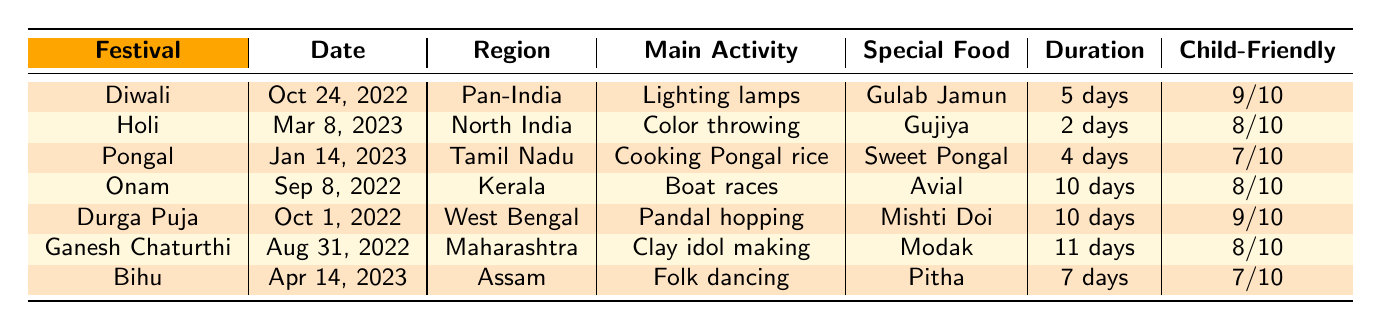What is the special food for Diwali? The table lists the special food associated with each festival. According to the row for Diwali, the special food is Gulab Jamun.
Answer: Gulab Jamun How many days does Holi last? Looking at the table, the duration of Holi is indicated as 2 days, which can be found in the same row as the festival name.
Answer: 2 days Which festival has the highest child-friendly rating? The table provides child-friendly ratings for each festival. By comparing the ratings, Diwali and Durga Puja both have a rating of 9, which is the highest.
Answer: Diwali and Durga Puja What is the main activity during Pongal? The main activity for each festival is stated in the table. For Pongal, it is "Cooking Pongal rice," which is found in its respective row.
Answer: Cooking Pongal rice Which festival occurring in Kerala lasts the longest? From the table, Onam is the festival in Kerala with a duration of 10 days, which is the longest among the festivals listed for that region.
Answer: Onam How many days is the duration of Ganesh Chaturthi compared to Holi? According to the table, Ganesh Chaturthi lasts for 11 days, while Holi lasts for 2 days. The difference in duration is 11 - 2 = 9 days.
Answer: 11 days vs. 2 days Is Bihu a child-friendly festival? The child-friendly rating for Bihu is 7, which indicates that it is relatively child-friendly, although not as high as some others, but it can still be categorized as such.
Answer: Yes What is the main activity of Onam and how many days does it last? For Onam, the main activity is "Boat races," and the duration is 10 days, both of which can be found in the corresponding row in the table.
Answer: Boat races, 10 days If you combine the durations of Holi, Pongal, and Onam, what is the total duration? The durations for Holi (2 days), Pongal (4 days), and Onam (10 days) can be summed: 2 + 4 + 10 = 16 days.
Answer: 16 days Which festival takes place in North India and occurs in March? The table indicates that Holi takes place in North India and is dated March 8, 2023.
Answer: Holi 